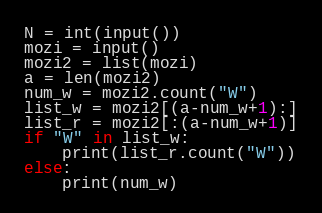Convert code to text. <code><loc_0><loc_0><loc_500><loc_500><_Python_>N = int(input())
mozi = input()
mozi2 = list(mozi)
a = len(mozi2)
num_w = mozi2.count("W")
list_w = mozi2[(a-num_w+1):]
list_r = mozi2[:(a-num_w+1)]
if "W" in list_w:
    print(list_r.count("W"))
else:
    print(num_w)</code> 